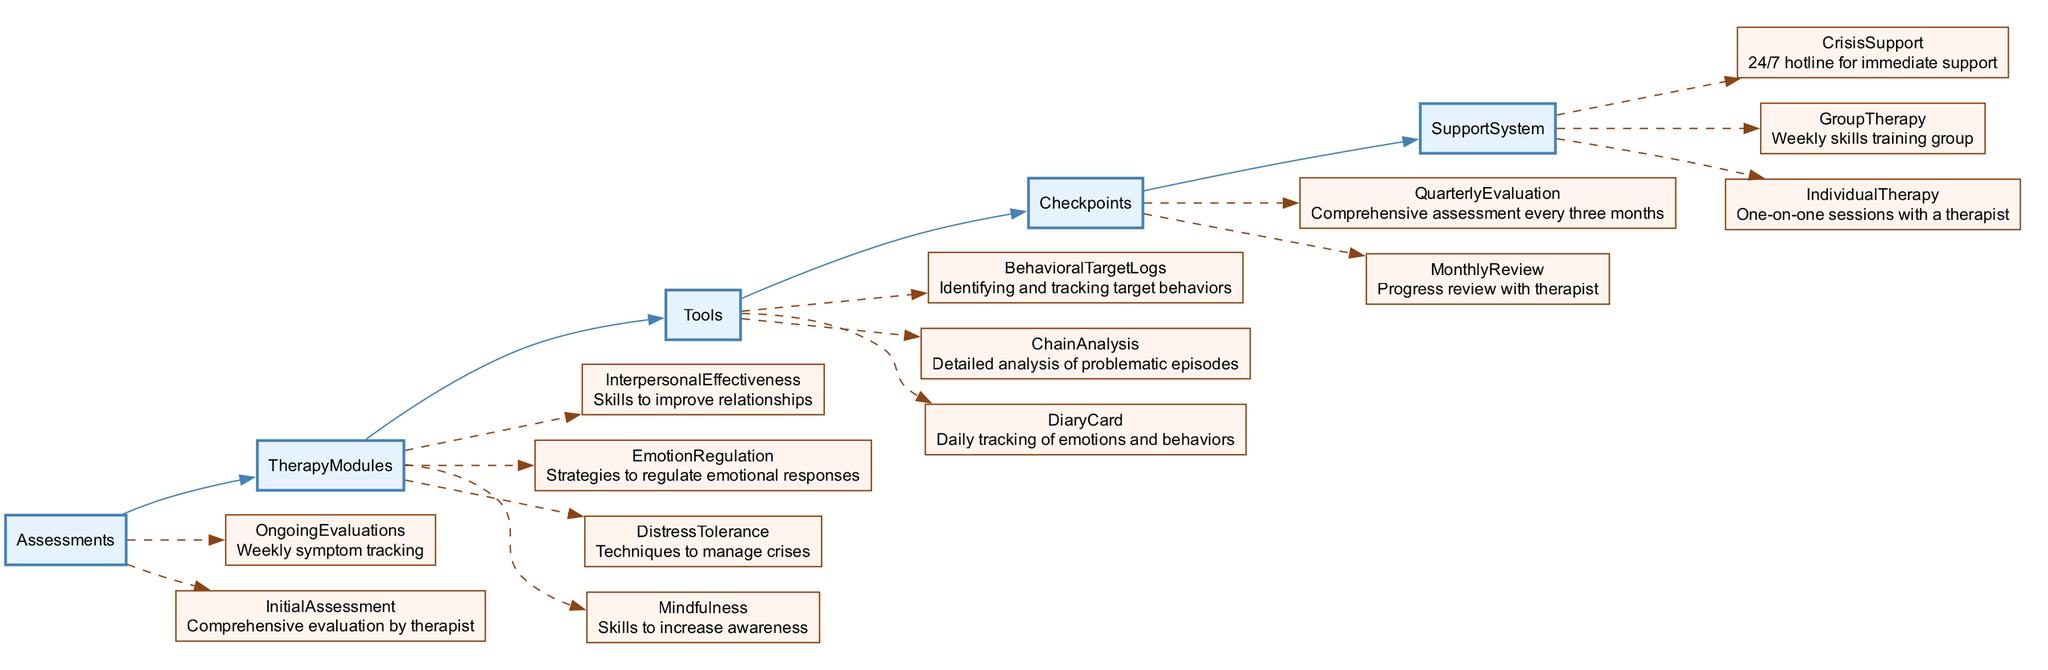What is the first step in the DBT clinical pathway? The first step in the pathway is the "InitialAssessment", which is described as a "Comprehensive evaluation by therapist". This indicates the starting point of the DBT process.
Answer: InitialAssessment How many therapy modules are there in DBT? The diagram shows four therapy modules: Mindfulness, DistressTolerance, EmotionRegulation, and InterpersonalEffectiveness. Counting these provides the total number of modules.
Answer: 4 What do "OngoingEvaluations" consist of? The "OngoingEvaluations" are described as "Weekly symptom tracking", which indicates the method of tracking progress during the therapy.
Answer: Weekly symptom tracking What forms the checkpoint for progress in DBT? The diagram outlines two checkpoints: "MonthlyReview" and "QuarterlyEvaluation". The presence of these two different reviews highlights the structured approach to monitoring progress.
Answer: MonthlyReview and QuarterlyEvaluation Which node connects to the "CrisisSupport"? The connection format in the diagram shows that "SupportSystem" connects to "CrisisSupport". This denotes that crisis support is part of the broader support provided in DBT.
Answer: SupportSystem Which therapy module focuses on managing crises? Among the therapy modules listed in the diagram, "DistressTolerance" is specifically designed for managing crises, as indicated by its title.
Answer: DistressTolerance What tools are used for behavior tracking? The tools for behavior tracking include "DiaryCard", "ChainAnalysis", and "BehavioralTargetLogs". These tools combine to aid in the monitoring of behaviors during therapy.
Answer: DiaryCard, ChainAnalysis, and BehavioralTargetLogs How often is the comprehensive assessment conducted? According to the pathway, the "QuarterlyEvaluation" is stated to take place every three months, indicating the frequency of comprehensive assessments within the therapy framework.
Answer: Every three months 